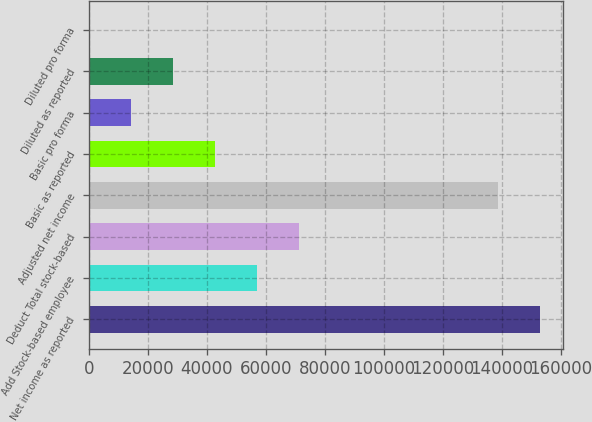Convert chart. <chart><loc_0><loc_0><loc_500><loc_500><bar_chart><fcel>Net income as reported<fcel>Add Stock-based employee<fcel>Deduct Total stock-based<fcel>Adjusted net income<fcel>Basic as reported<fcel>Basic pro forma<fcel>Diluted as reported<fcel>Diluted pro forma<nl><fcel>153127<fcel>57102.5<fcel>71377.9<fcel>138852<fcel>42827.1<fcel>14276.2<fcel>28551.7<fcel>0.83<nl></chart> 